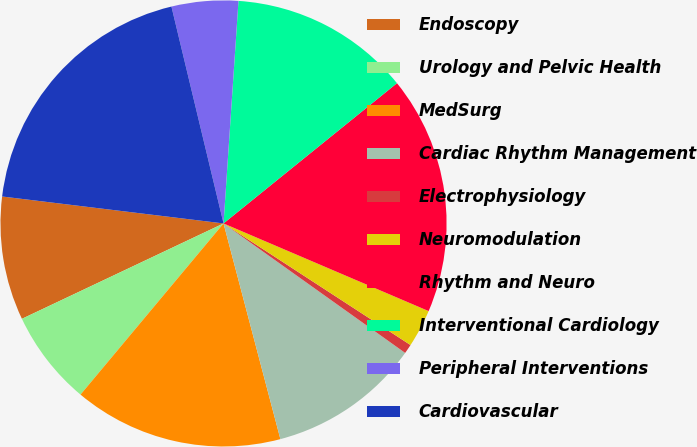Convert chart. <chart><loc_0><loc_0><loc_500><loc_500><pie_chart><fcel>Endoscopy<fcel>Urology and Pelvic Health<fcel>MedSurg<fcel>Cardiac Rhythm Management<fcel>Electrophysiology<fcel>Neuromodulation<fcel>Rhythm and Neuro<fcel>Interventional Cardiology<fcel>Peripheral Interventions<fcel>Cardiovascular<nl><fcel>8.96%<fcel>6.89%<fcel>15.18%<fcel>11.04%<fcel>0.68%<fcel>2.75%<fcel>17.25%<fcel>13.11%<fcel>4.82%<fcel>19.32%<nl></chart> 